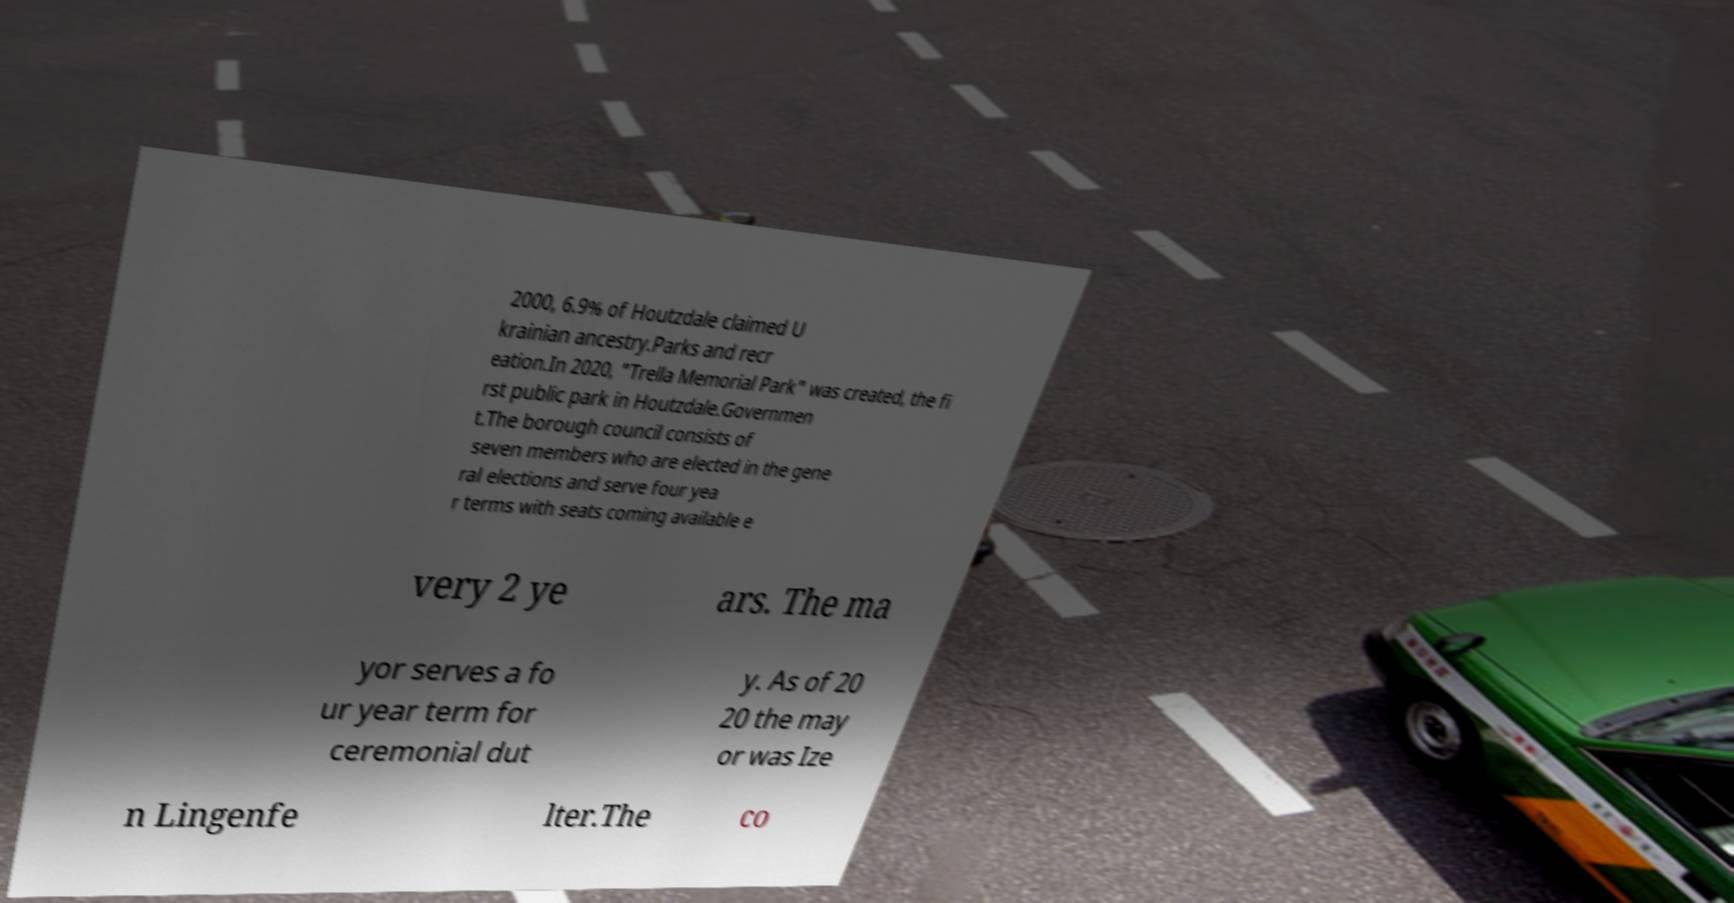Could you extract and type out the text from this image? 2000, 6.9% of Houtzdale claimed U krainian ancestry.Parks and recr eation.In 2020, "Trella Memorial Park" was created, the fi rst public park in Houtzdale.Governmen t.The borough council consists of seven members who are elected in the gene ral elections and serve four yea r terms with seats coming available e very 2 ye ars. The ma yor serves a fo ur year term for ceremonial dut y. As of 20 20 the may or was Ize n Lingenfe lter.The co 